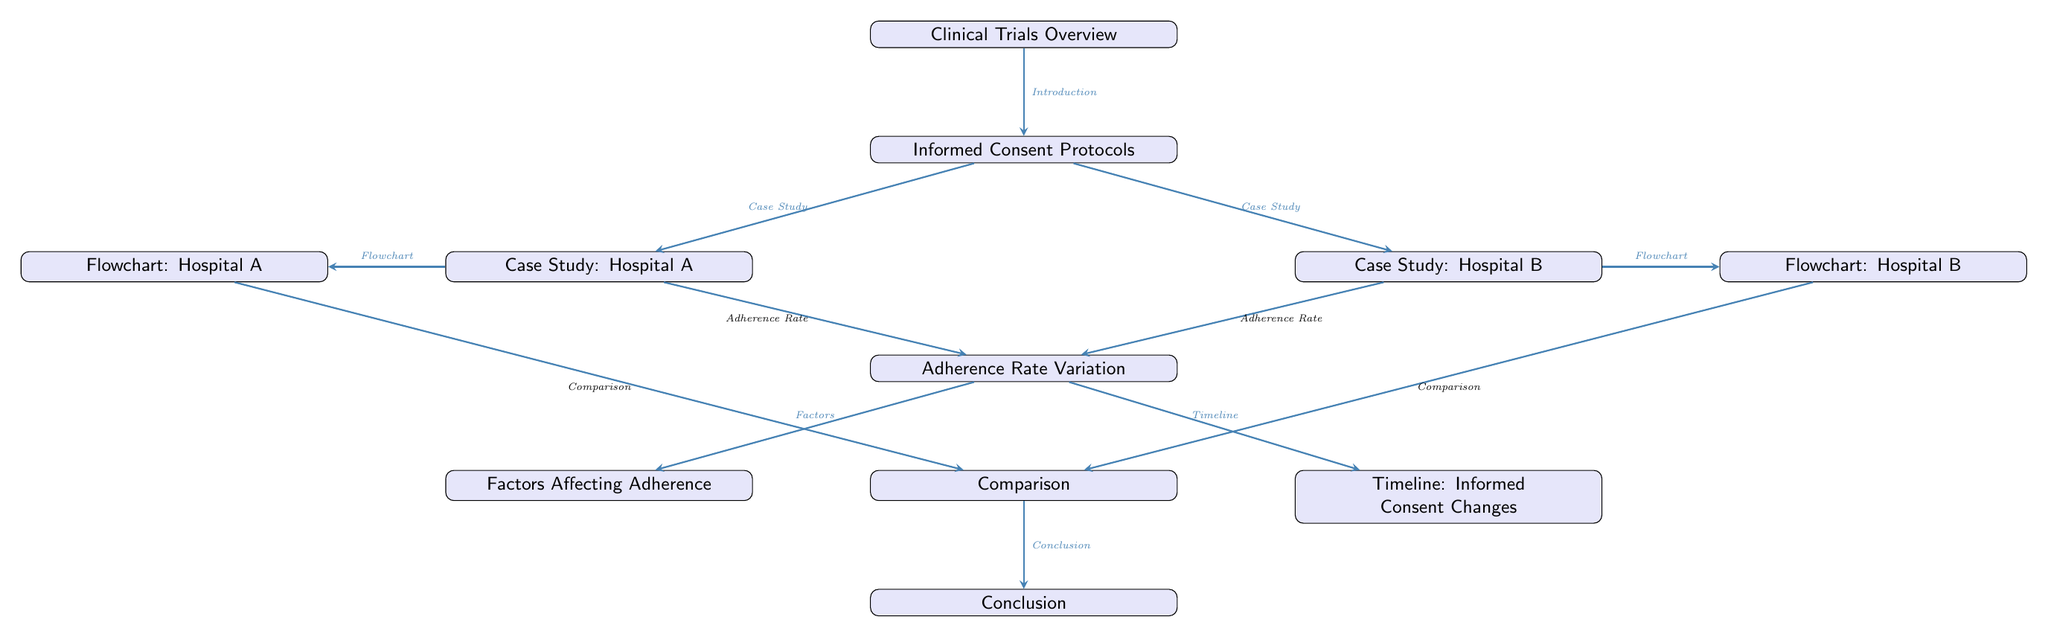What is the title of the first node? The first node in the diagram is labeled "Clinical Trials Overview", indicating it serves as the introductory element that presents the main topic of the diagram.
Answer: Clinical Trials Overview How many case studies are presented in the diagram? The diagram includes two case studies labeled "Case Study: Hospital A" and "Case Study: Hospital B", showing that it focuses on two specific healthcare settings.
Answer: 2 What do the arrows between "Informed Consent Protocols" and both case studies indicate? The arrows lead from "Informed Consent Protocols" to both "Case Study: Hospital A" and "Case Study: Hospital B", which implies that both case studies are related to or drawn from the protocols established for informed consent.
Answer: Related What is the main result derived from the case studies? The diagram shows "Adherence Rate Variation" as a key output below the case studies, suggesting that a primary focus is the differences in adherence rates to informed consent protocols between the two hospitals.
Answer: Adherence Rate Variation What are the two sources of factors affecting adherence listed in the diagram? The diagram connects "Factors Affecting Adherence" to "Adherence Rate Variation," indicating that various factors impact how closely the hospitals follow informed consent protocols.
Answer: Factors Affecting Adherence What shapes represent the nodes in the diagram? The nodes in the diagram are represented as rectangles with rounded corners, signifying a consistent visual format for presenting components of the analysis.
Answer: Rectangles with rounded corners What is the relationship between "Timeline: Informed Consent Changes" and "Comparison"? The "Timeline: Informed Consent Changes" node is connected to the "Comparison" node, which implies that the timeline is an essential part of comparing how informed consent practices evolved in both case studies.
Answer: Essential part From which node does the conclusion derive? The conclusion is derived from the "Comparison" node, suggesting that the findings from the comparisons drawn between the two hospital case studies lead to an overall conclusion regarding informed consent adherence.
Answer: Comparison 